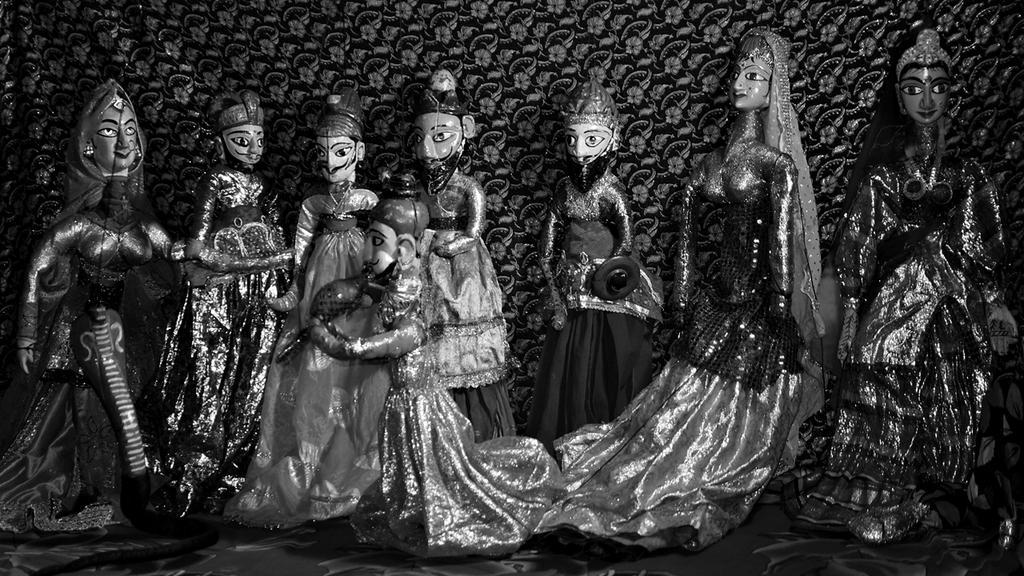Can you describe this image briefly? In the center of the image dolls are present. At the bottom of the image floor is there. At the top of the image wall is there. 